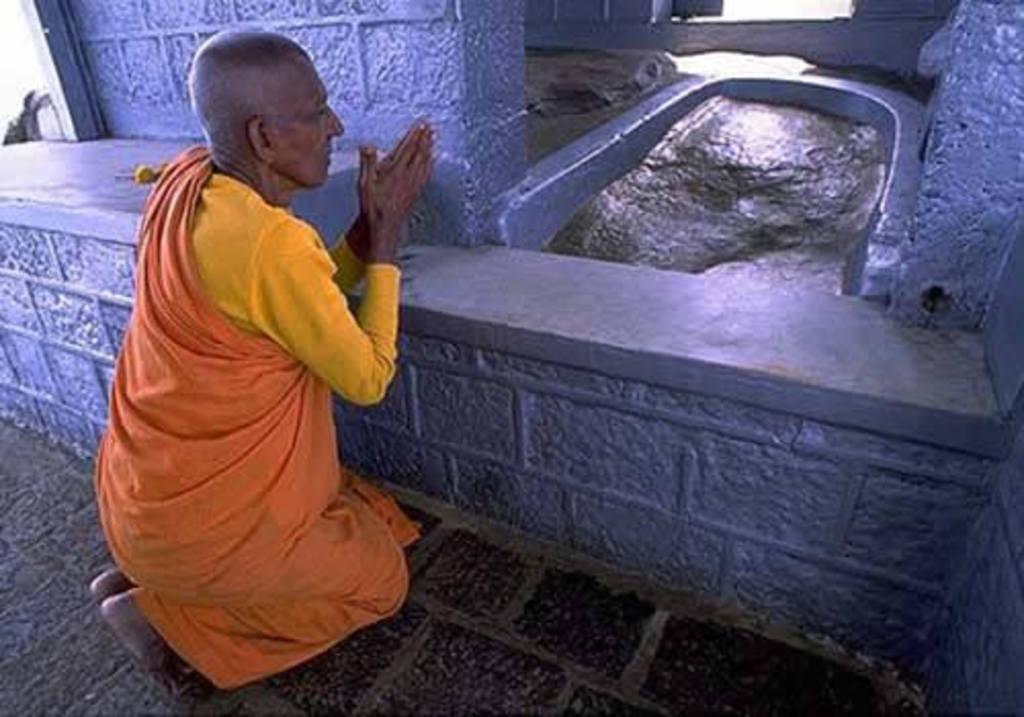How would you summarize this image in a sentence or two? In this image we can see a person wearing orange color dress and sitting on his knees and doing prayer. 